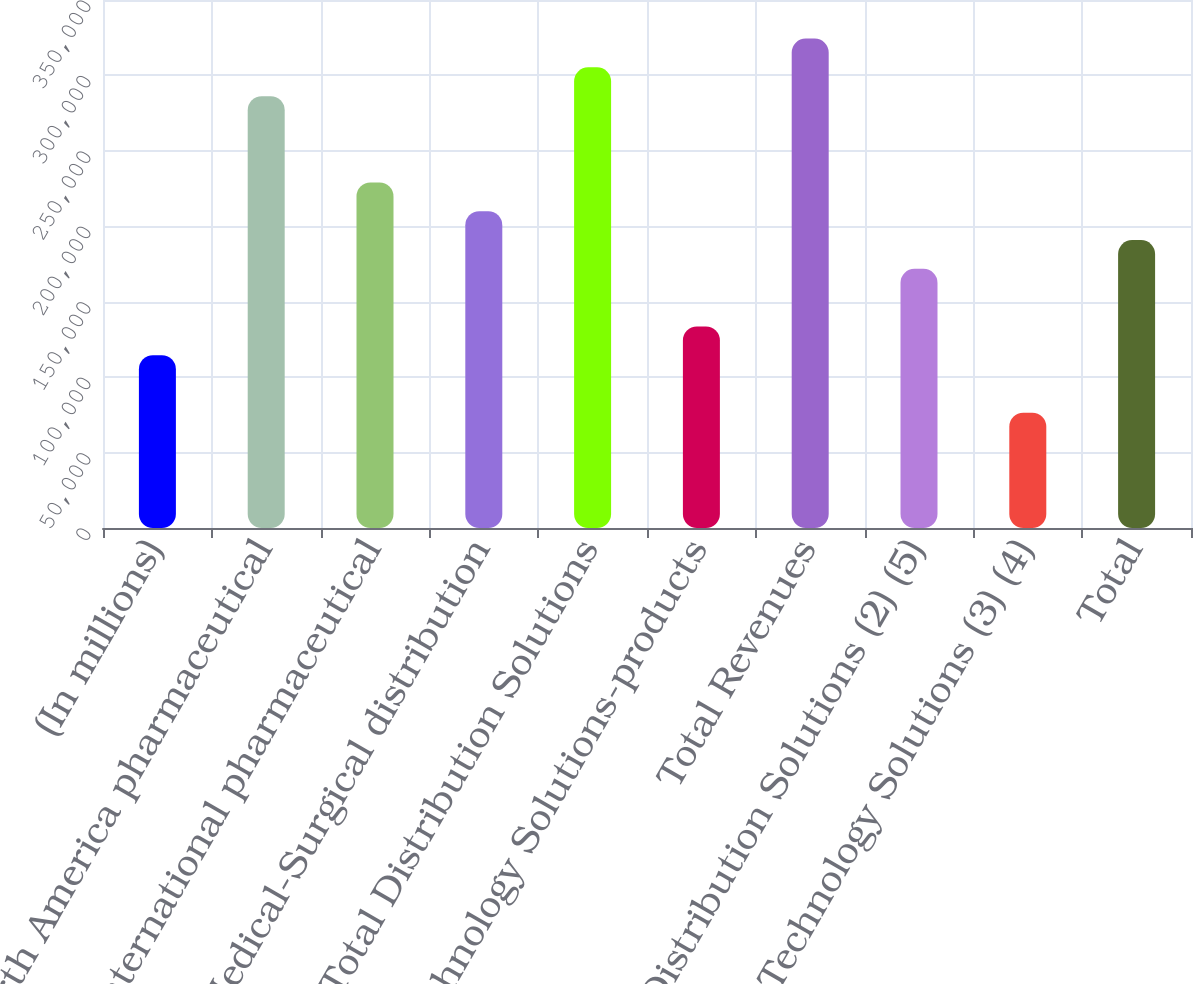Convert chart to OTSL. <chart><loc_0><loc_0><loc_500><loc_500><bar_chart><fcel>(In millions)<fcel>North America pharmaceutical<fcel>International pharmaceutical<fcel>Medical-Surgical distribution<fcel>Total Distribution Solutions<fcel>Technology Solutions-products<fcel>Total Revenues<fcel>Distribution Solutions (2) (5)<fcel>Technology Solutions (3) (4)<fcel>Total<nl><fcel>114573<fcel>286272<fcel>229039<fcel>209962<fcel>305350<fcel>133651<fcel>324428<fcel>171806<fcel>76417.8<fcel>190884<nl></chart> 